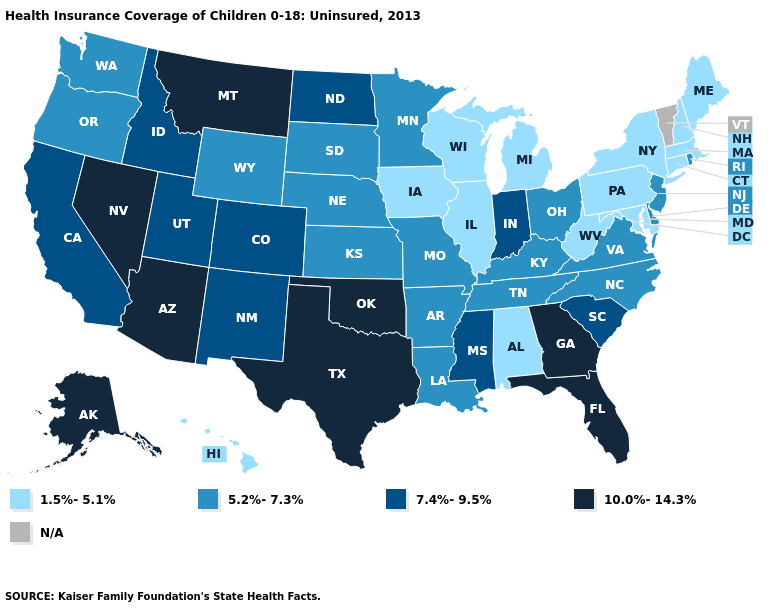Does Kansas have the lowest value in the USA?
Give a very brief answer. No. Name the states that have a value in the range N/A?
Answer briefly. Vermont. Name the states that have a value in the range 10.0%-14.3%?
Quick response, please. Alaska, Arizona, Florida, Georgia, Montana, Nevada, Oklahoma, Texas. Which states hav the highest value in the West?
Keep it brief. Alaska, Arizona, Montana, Nevada. What is the lowest value in the USA?
Quick response, please. 1.5%-5.1%. Does Hawaii have the lowest value in the West?
Concise answer only. Yes. What is the value of Arkansas?
Write a very short answer. 5.2%-7.3%. What is the value of Ohio?
Write a very short answer. 5.2%-7.3%. What is the value of Kentucky?
Give a very brief answer. 5.2%-7.3%. Among the states that border Tennessee , which have the lowest value?
Short answer required. Alabama. Which states have the highest value in the USA?
Give a very brief answer. Alaska, Arizona, Florida, Georgia, Montana, Nevada, Oklahoma, Texas. Name the states that have a value in the range 10.0%-14.3%?
Concise answer only. Alaska, Arizona, Florida, Georgia, Montana, Nevada, Oklahoma, Texas. Among the states that border Rhode Island , which have the highest value?
Keep it brief. Connecticut, Massachusetts. Among the states that border Minnesota , does North Dakota have the lowest value?
Short answer required. No. 